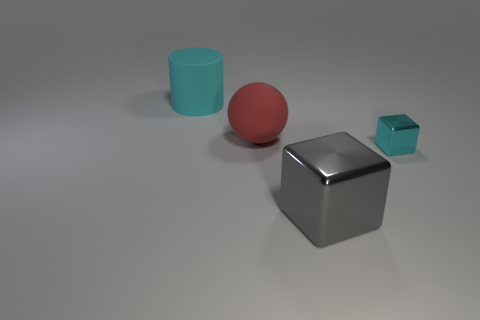Add 3 small cyan blocks. How many objects exist? 7 Add 1 large cylinders. How many large cylinders are left? 2 Add 3 small yellow matte cylinders. How many small yellow matte cylinders exist? 3 Subtract 0 brown cylinders. How many objects are left? 4 Subtract all large yellow cubes. Subtract all tiny cyan cubes. How many objects are left? 3 